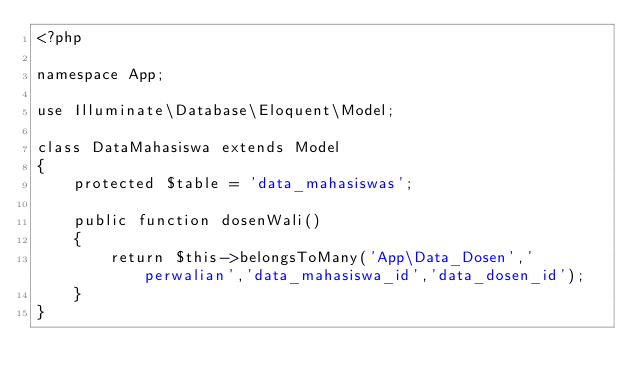Convert code to text. <code><loc_0><loc_0><loc_500><loc_500><_PHP_><?php

namespace App;

use Illuminate\Database\Eloquent\Model;

class DataMahasiswa extends Model
{
    protected $table = 'data_mahasiswas';

    public function dosenWali()
    {
        return $this->belongsToMany('App\Data_Dosen','perwalian','data_mahasiswa_id','data_dosen_id');
    }
}
</code> 